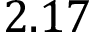Convert formula to latex. <formula><loc_0><loc_0><loc_500><loc_500>2 . 1 7</formula> 